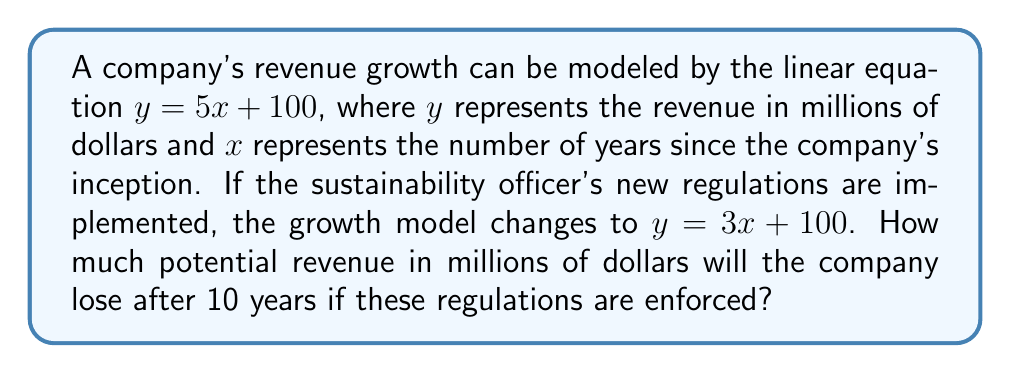Provide a solution to this math problem. 1. Calculate revenue without regulations after 10 years:
   $y = 5x + 100$
   $y = 5(10) + 100 = 150$ million dollars

2. Calculate revenue with regulations after 10 years:
   $y = 3x + 100$
   $y = 3(10) + 100 = 130$ million dollars

3. Calculate the difference in revenue:
   $150 - 130 = 20$ million dollars

Therefore, the company will lose $20 million in potential revenue after 10 years if the sustainability regulations are enforced.
Answer: $20 million 